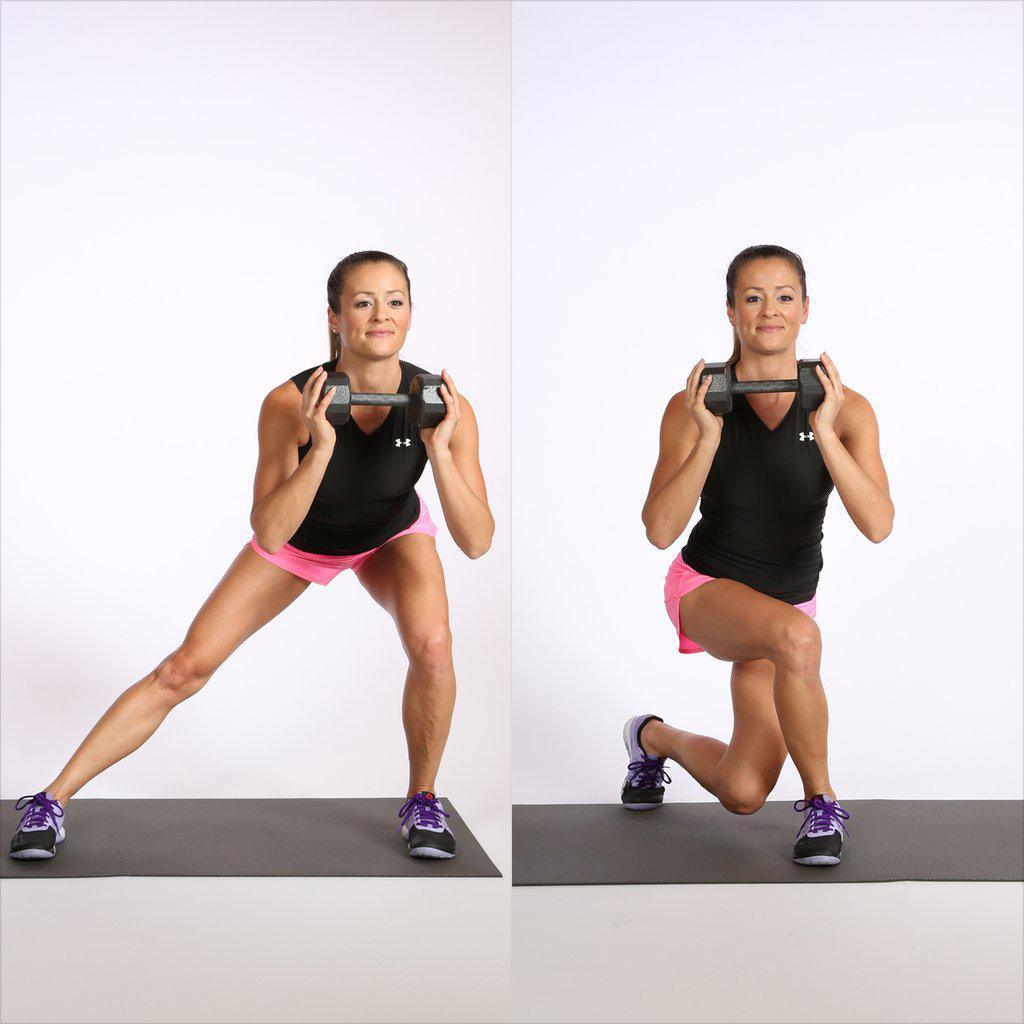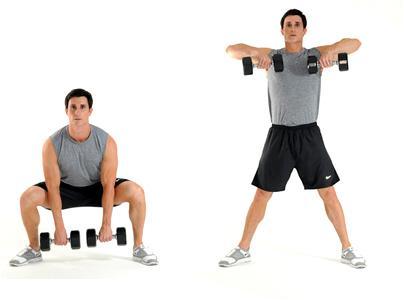The first image is the image on the left, the second image is the image on the right. For the images displayed, is the sentence "Each image shows a woman demonstrating at least two different positions in a dumbbell workout." factually correct? Answer yes or no. No. The first image is the image on the left, the second image is the image on the right. Assess this claim about the two images: "The left and right image contains the same number of women using weights.". Correct or not? Answer yes or no. No. 